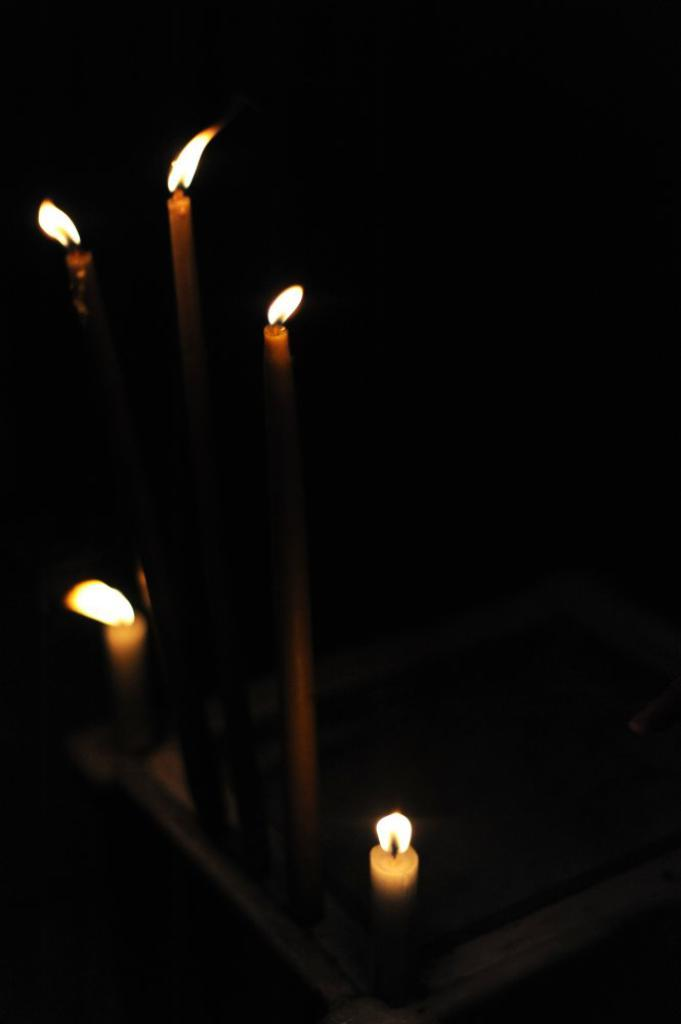What objects can be seen in the image? There are candles in the image. Can you describe the lighting conditions in the image? The image is dark. What type of carriage can be seen in the image? There is no carriage present in the image; it only features candles. What liquid is being poured from the candles in the image? The candles in the image are not pouring any liquid; they are stationary. 